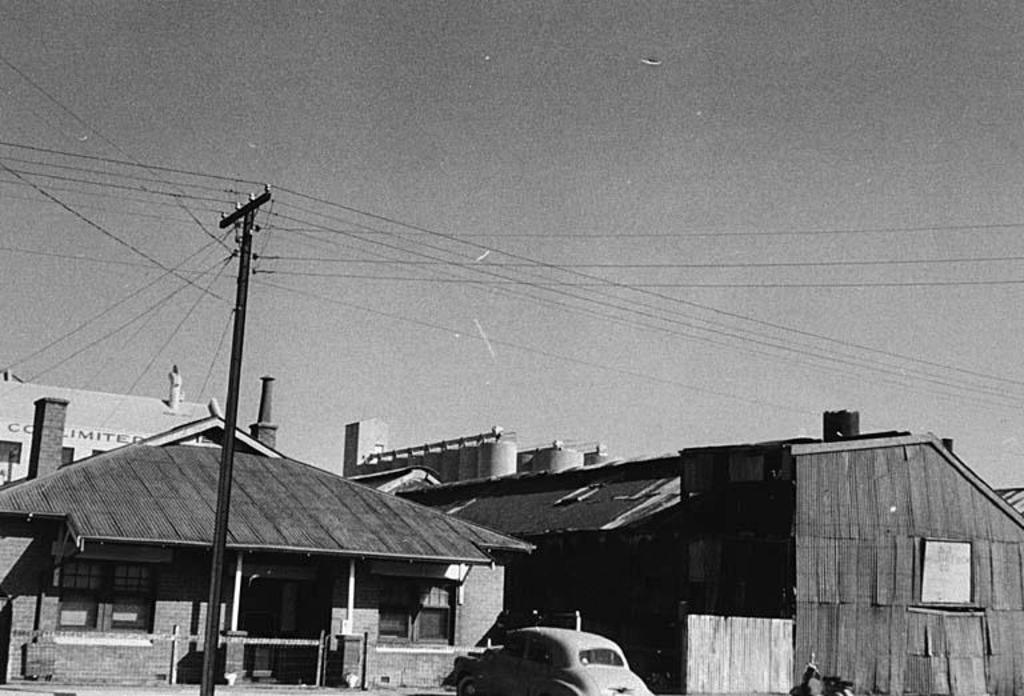Can you describe this image briefly? At the bottom of the image there are sheds and a car. On the left there is a pole. At the top there are wires and sky. 